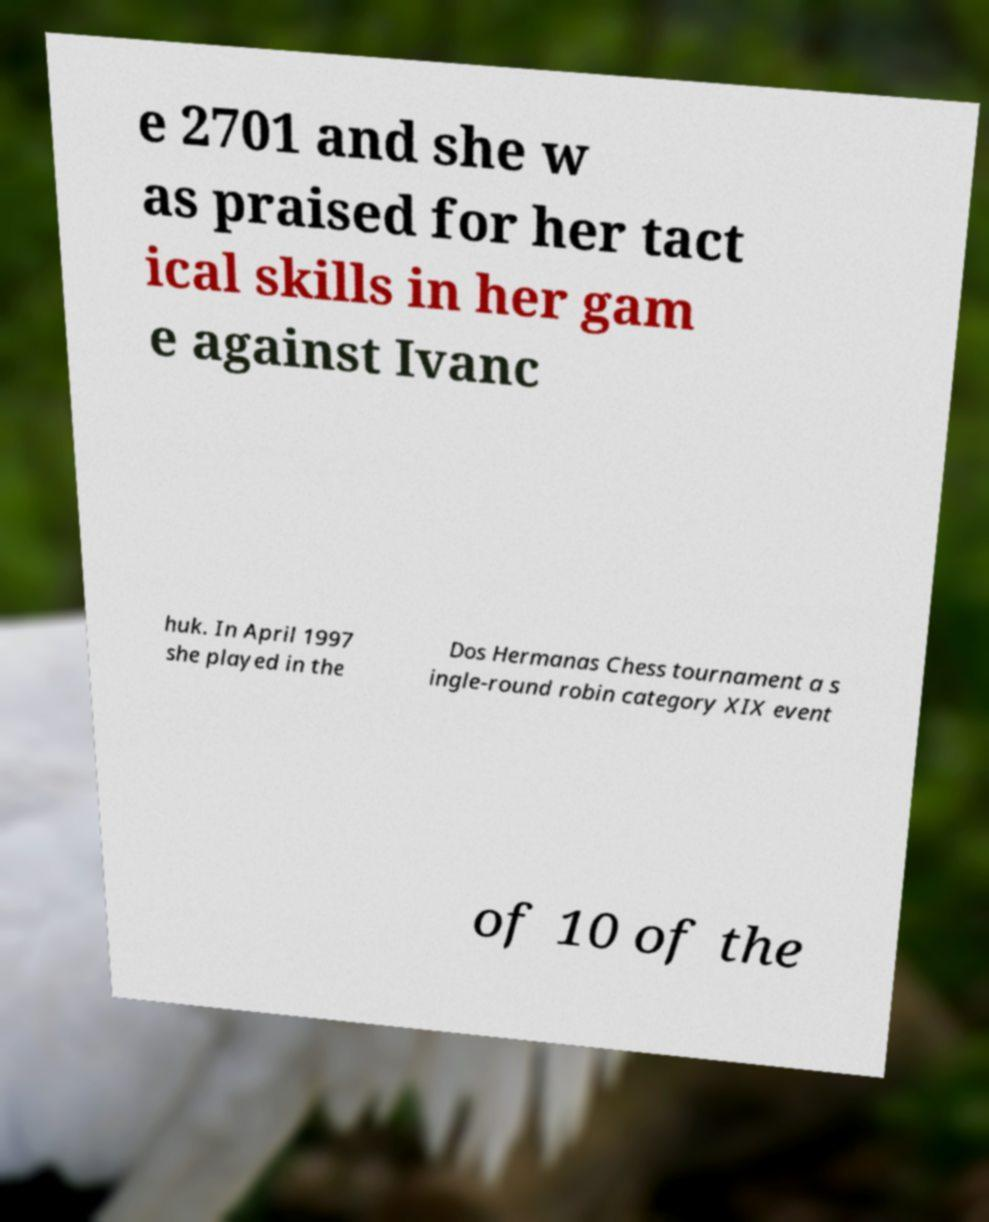Please identify and transcribe the text found in this image. e 2701 and she w as praised for her tact ical skills in her gam e against Ivanc huk. In April 1997 she played in the Dos Hermanas Chess tournament a s ingle-round robin category XIX event of 10 of the 